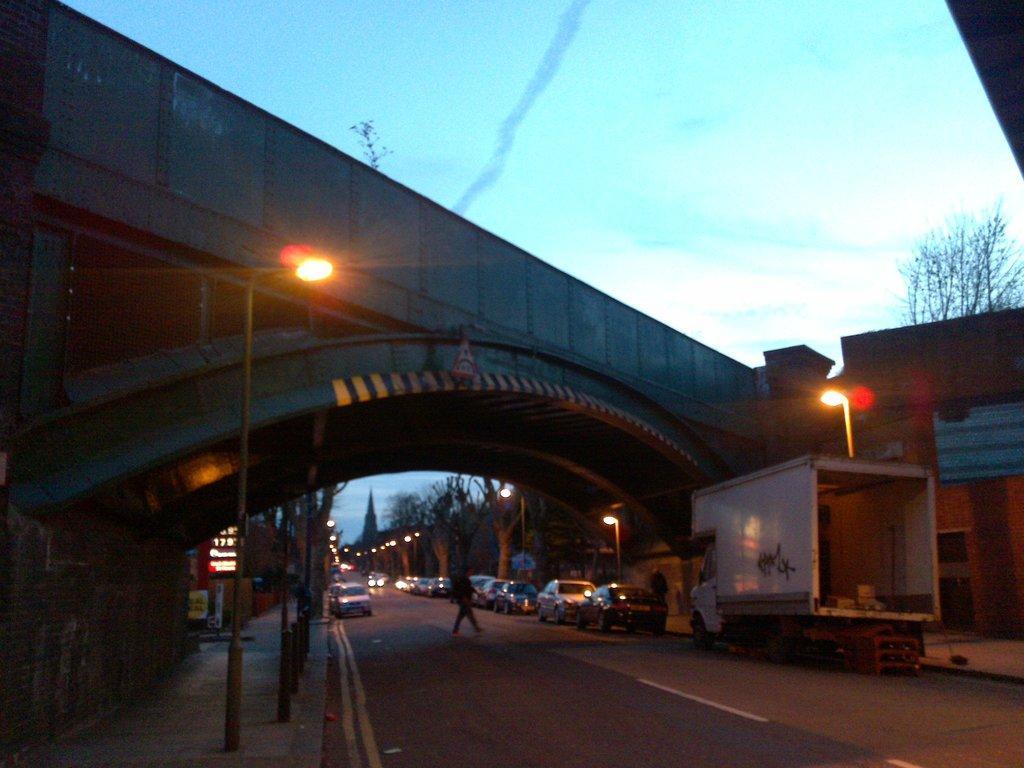Describe this image in one or two sentences. This picture consists of bridge , under the bridge there is a road, on the road there are street light poles, person walking on road, few vehicles, truck visible ,at the top there is the sky. 